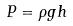Convert formula to latex. <formula><loc_0><loc_0><loc_500><loc_500>P = \rho g h</formula> 